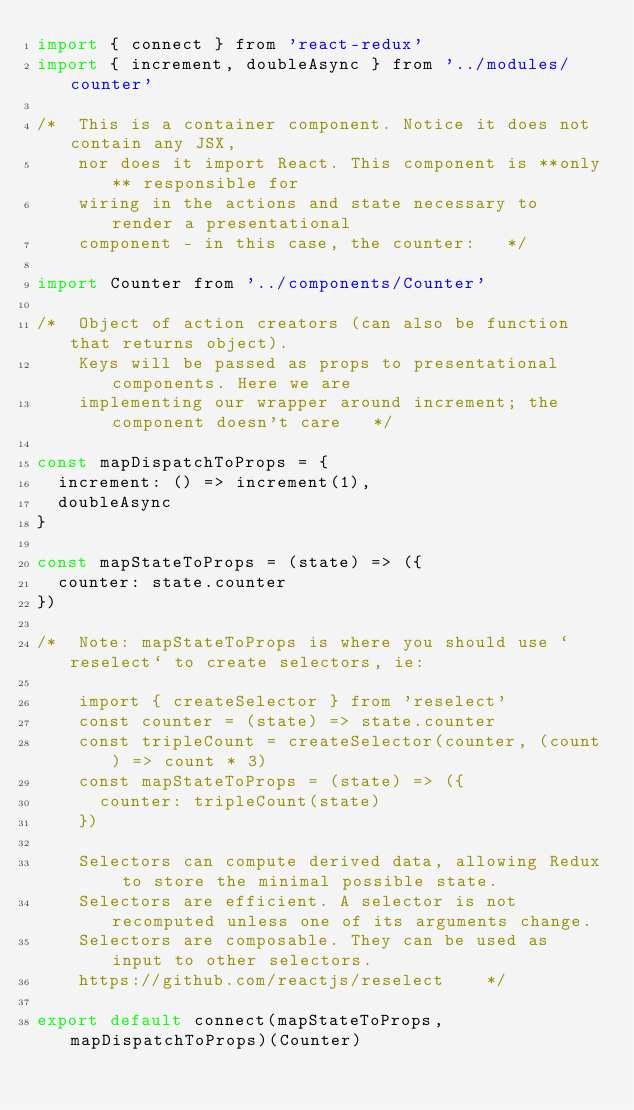Convert code to text. <code><loc_0><loc_0><loc_500><loc_500><_JavaScript_>import { connect } from 'react-redux'
import { increment, doubleAsync } from '../modules/counter'

/*  This is a container component. Notice it does not contain any JSX,
    nor does it import React. This component is **only** responsible for
    wiring in the actions and state necessary to render a presentational
    component - in this case, the counter:   */

import Counter from '../components/Counter'

/*  Object of action creators (can also be function that returns object).
    Keys will be passed as props to presentational components. Here we are
    implementing our wrapper around increment; the component doesn't care   */

const mapDispatchToProps = {
  increment: () => increment(1),
  doubleAsync
}

const mapStateToProps = (state) => ({
  counter: state.counter
})

/*  Note: mapStateToProps is where you should use `reselect` to create selectors, ie:

    import { createSelector } from 'reselect'
    const counter = (state) => state.counter
    const tripleCount = createSelector(counter, (count) => count * 3)
    const mapStateToProps = (state) => ({
      counter: tripleCount(state)
    })

    Selectors can compute derived data, allowing Redux to store the minimal possible state.
    Selectors are efficient. A selector is not recomputed unless one of its arguments change.
    Selectors are composable. They can be used as input to other selectors.
    https://github.com/reactjs/reselect    */

export default connect(mapStateToProps, mapDispatchToProps)(Counter)
</code> 